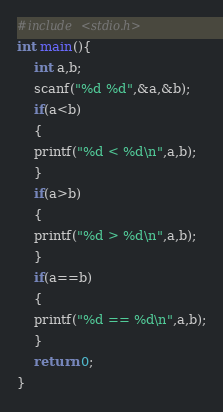Convert code to text. <code><loc_0><loc_0><loc_500><loc_500><_C++_>#include <stdio.h>
int main(){
    int a,b;
    scanf("%d %d",&a,&b);
    if(a<b)
    {
    printf("%d < %d\n",a,b);
    }
    if(a>b)
    {
    printf("%d > %d\n",a,b);
    }
    if(a==b)
    {
    printf("%d == %d\n",a,b);
    }
    return 0;
}</code> 